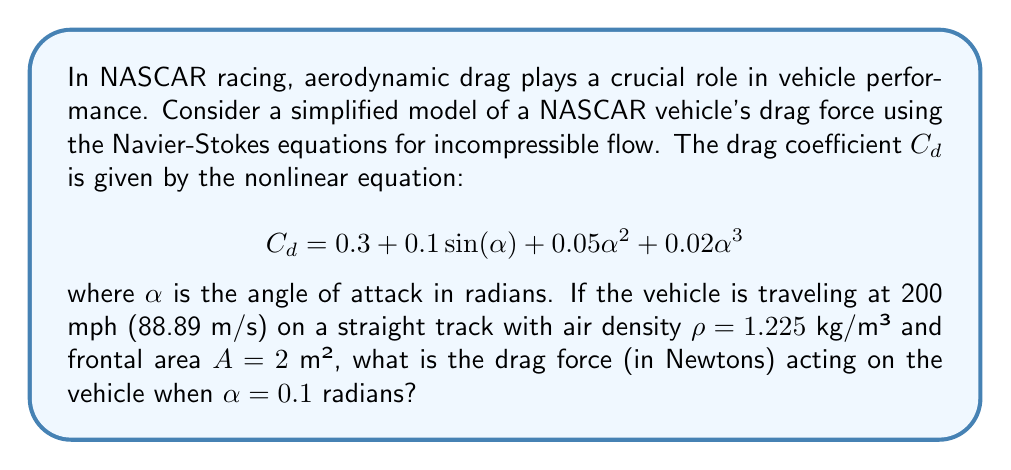Could you help me with this problem? Let's approach this step-by-step:

1) First, we need to calculate the drag coefficient $C_d$ using the given equation:

   $$C_d = 0.3 + 0.1\sin(0.1) + 0.05(0.1)^2 + 0.02(0.1)^3$$

2) Let's evaluate each term:
   - $0.3$ is constant
   - $0.1\sin(0.1) \approx 0.00998$
   - $0.05(0.1)^2 = 0.0005$
   - $0.02(0.1)^3 = 0.00002$

3) Adding these up:
   $$C_d \approx 0.3 + 0.00998 + 0.0005 + 0.00002 \approx 0.3105$$

4) Now, we can use the drag force equation:

   $$F_d = \frac{1}{2}\rho v^2 A C_d$$

   where:
   - $F_d$ is the drag force
   - $\rho$ is the air density (1.225 kg/m³)
   - $v$ is the velocity (88.89 m/s)
   - $A$ is the frontal area (2 m²)
   - $C_d$ is the drag coefficient we just calculated (0.3105)

5) Substituting these values:

   $$F_d = \frac{1}{2}(1.225)(88.89^2)(2)(0.3105)$$

6) Calculating:
   $$F_d \approx 2,372.76 \text{ N}$$

Therefore, the drag force acting on the NASCAR vehicle is approximately 2,372.76 Newtons.
Answer: 2,372.76 N 